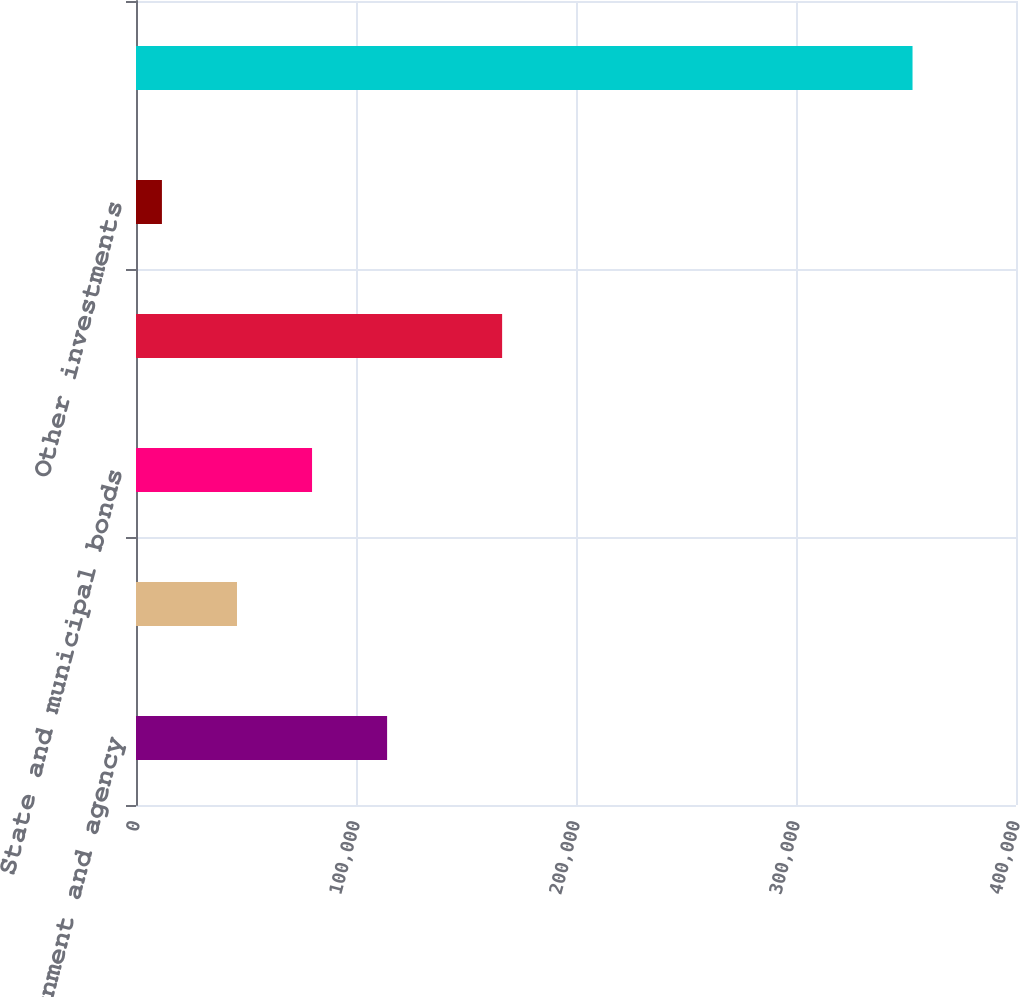Convert chart to OTSL. <chart><loc_0><loc_0><loc_500><loc_500><bar_chart><fcel>US government and agency<fcel>Obligations of government-<fcel>State and municipal bonds<fcel>Corporate securities<fcel>Other investments<fcel>Total investments<nl><fcel>114140<fcel>45903.3<fcel>80021.6<fcel>166420<fcel>11785<fcel>352968<nl></chart> 